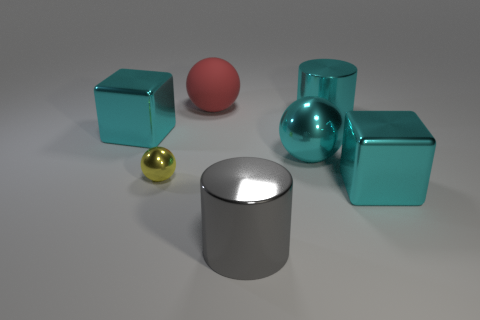Does the metal cylinder that is to the right of the big gray shiny thing have the same size as the metallic ball to the left of the big red matte thing?
Your answer should be very brief. No. What is the size of the ball that is on the left side of the large red matte sphere?
Provide a succinct answer. Small. There is a cylinder that is the same color as the big metallic sphere; what is its material?
Your response must be concise. Metal. What color is the shiny ball that is the same size as the gray metal thing?
Make the answer very short. Cyan. Is the size of the gray metal object the same as the cyan shiny cylinder?
Your answer should be very brief. Yes. There is a ball that is behind the tiny shiny object and in front of the large rubber sphere; what size is it?
Keep it short and to the point. Large. How many metallic objects are large yellow blocks or small yellow spheres?
Keep it short and to the point. 1. Is the number of cyan balls that are behind the small sphere greater than the number of small cyan spheres?
Give a very brief answer. Yes. What material is the large red sphere behind the small thing?
Ensure brevity in your answer.  Rubber. What number of cyan spheres have the same material as the cyan cylinder?
Make the answer very short. 1. 